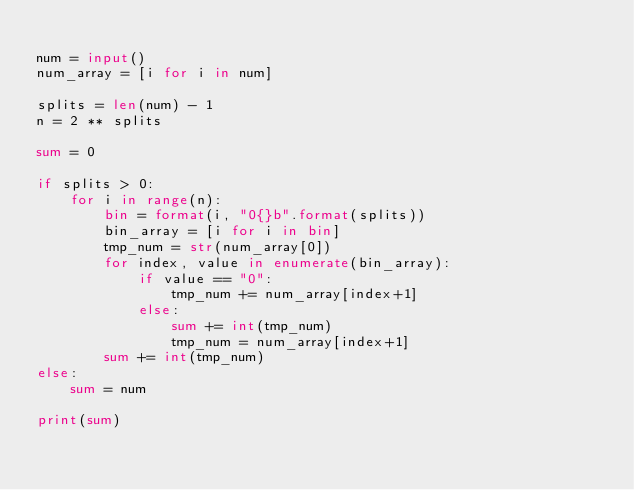Convert code to text. <code><loc_0><loc_0><loc_500><loc_500><_Python_>
num = input()
num_array = [i for i in num]

splits = len(num) - 1
n = 2 ** splits

sum = 0

if splits > 0:
    for i in range(n):
        bin = format(i, "0{}b".format(splits))
        bin_array = [i for i in bin]
        tmp_num = str(num_array[0])
        for index, value in enumerate(bin_array):
            if value == "0":
                tmp_num += num_array[index+1]
            else:
                sum += int(tmp_num)
                tmp_num = num_array[index+1]
        sum += int(tmp_num)
else:
    sum = num

print(sum)</code> 